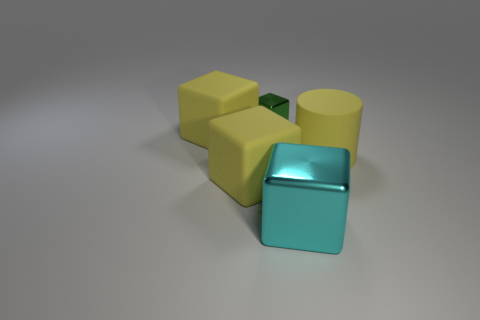How do the shadows in the image inform us about the light source? The shadows in the image are soft and extend towards the bottom right, suggesting that the light source is coming from the top left. This indicates diffuse lighting, possibly from a large source or through a filter that scatters the light. 